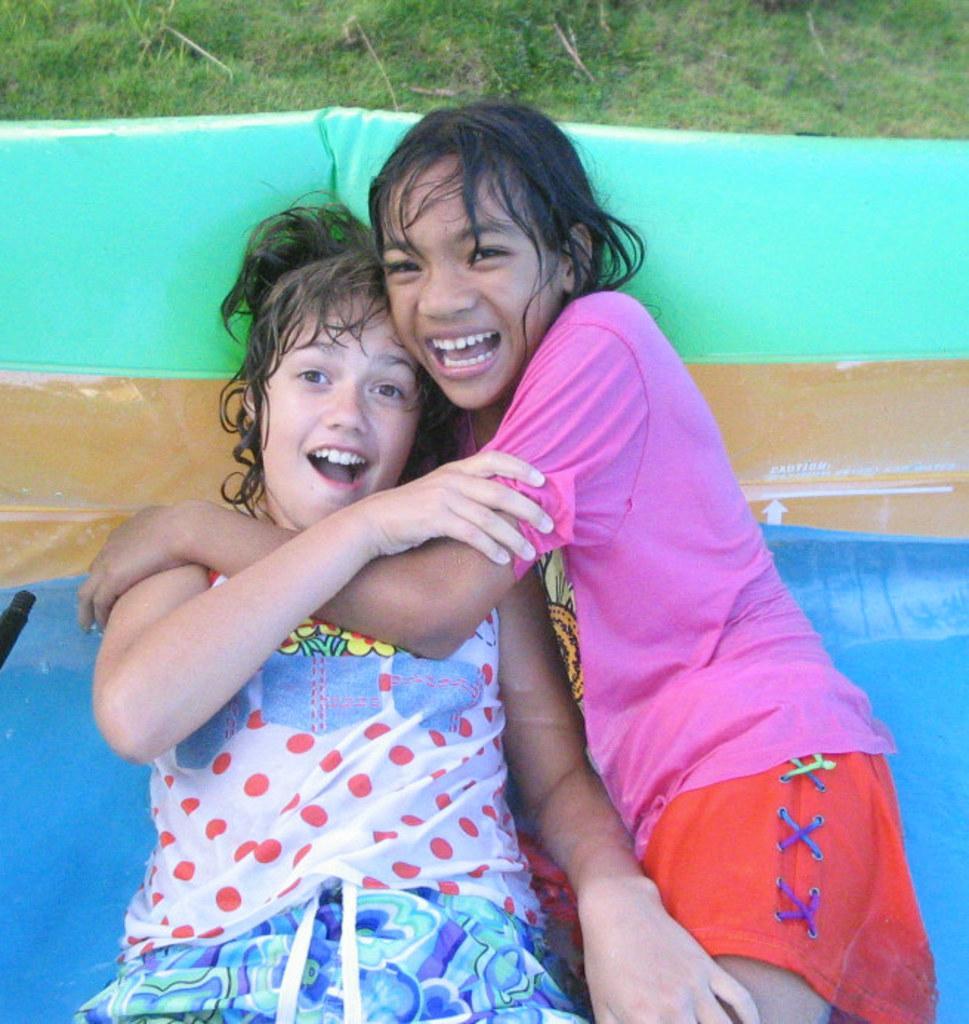In one or two sentences, can you explain what this image depicts? In the center of the image we can see two girls are lying on water slide. At the top of the image we can see some grass. 